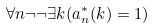Convert formula to latex. <formula><loc_0><loc_0><loc_500><loc_500>\forall n \neg \neg \exists k ( a ^ { * } _ { n } ( k ) = 1 )</formula> 